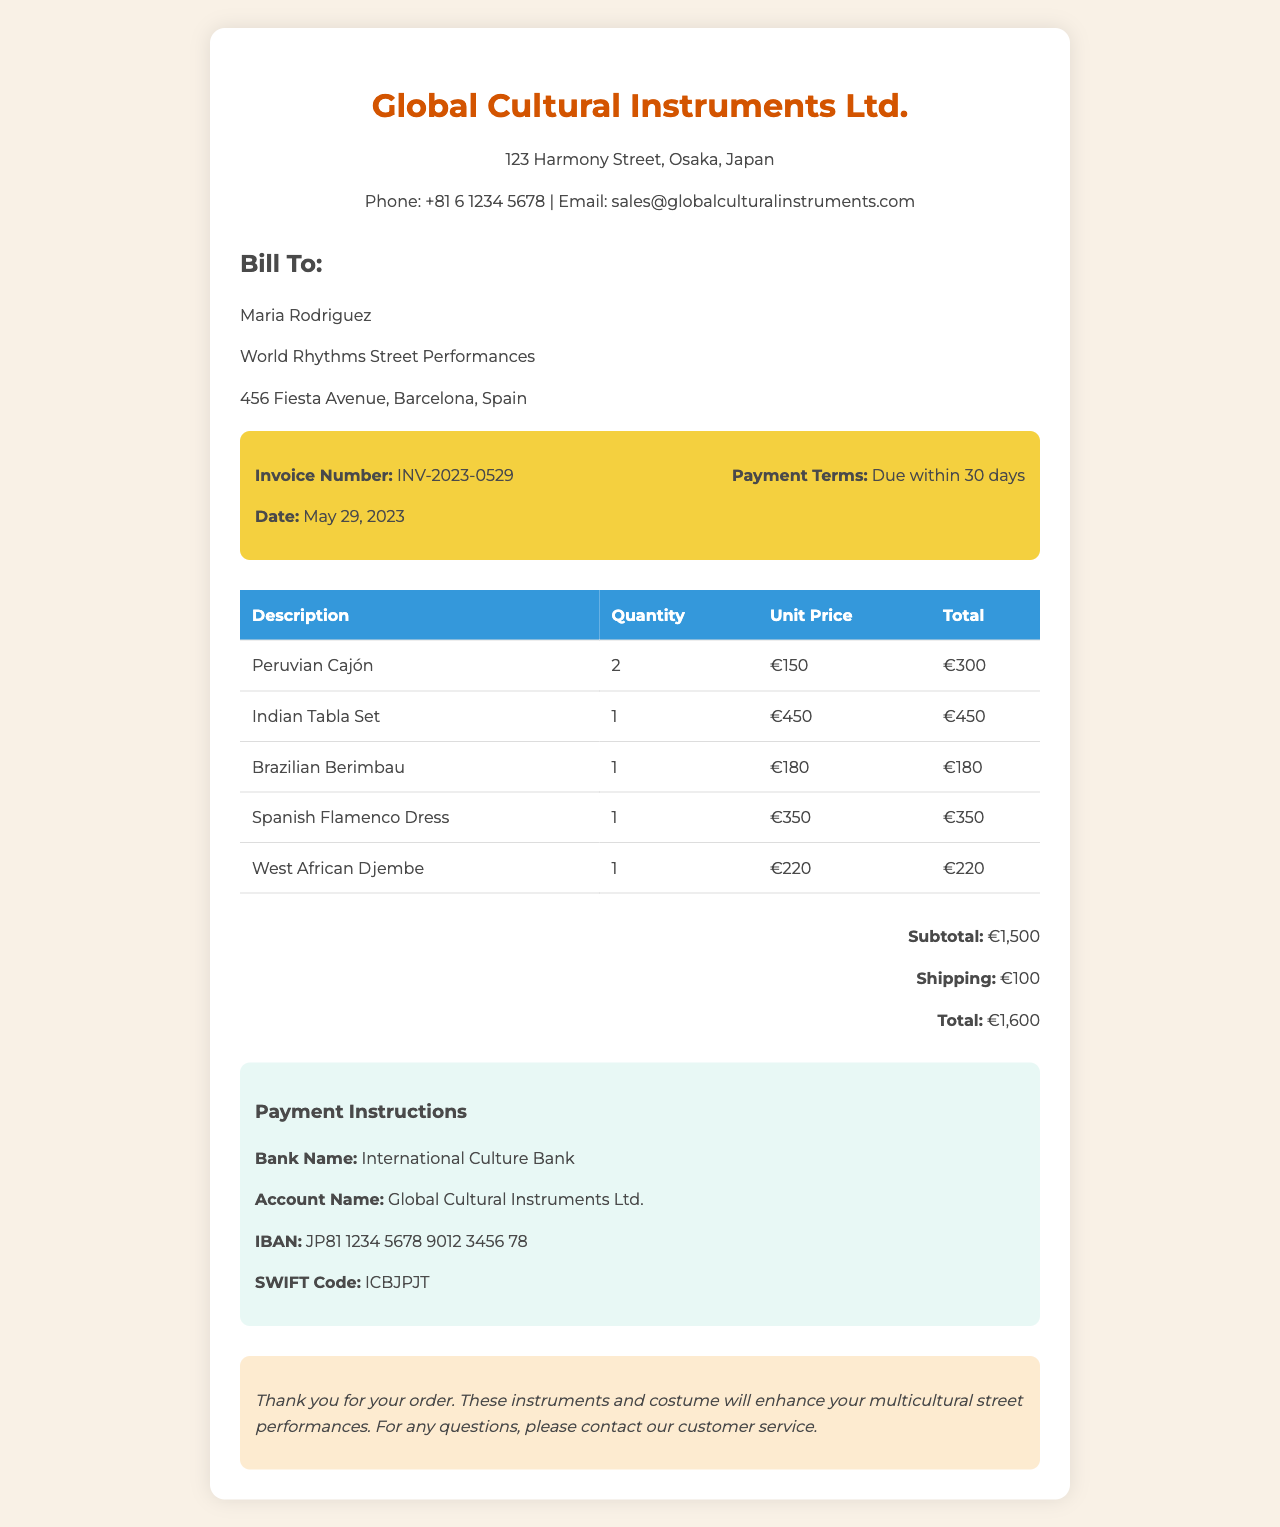What is the company name? The company name is presented at the top of the invoice as the provider of the instruments and costumes.
Answer: Global Cultural Instruments Ltd What is the invoice number? The invoice number is a unique identifier for the transaction as listed in the invoice details section.
Answer: INV-2023-0529 What is the date of the invoice? The date is specified in the invoice details section to indicate when the invoice was issued.
Answer: May 29, 2023 What is the total amount due? The total amount is calculated as the sum of the subtotal and shipping costs, listed in the total section.
Answer: €1,600 How many Peruvian Cajóns were purchased? The quantity of Peruvian Cajóns is stated in the itemized table of the invoice under description.
Answer: 2 What is the payment term? The payment term is mentioned in the invoice details to indicate when payment is expected.
Answer: Due within 30 days What is the shipping cost? The shipping cost is outlined in the total section of the invoice, indicating how much is added for delivery.
Answer: €100 Who is the recipient of the invoice? The recipient is identified in the recipient information section, providing the name and organization receiving the invoice.
Answer: Maria Rodriguez What type of payment methods are provided? The document includes details for electronic payment, indicating how the recipient should pay the invoice.
Answer: Bank transfer 